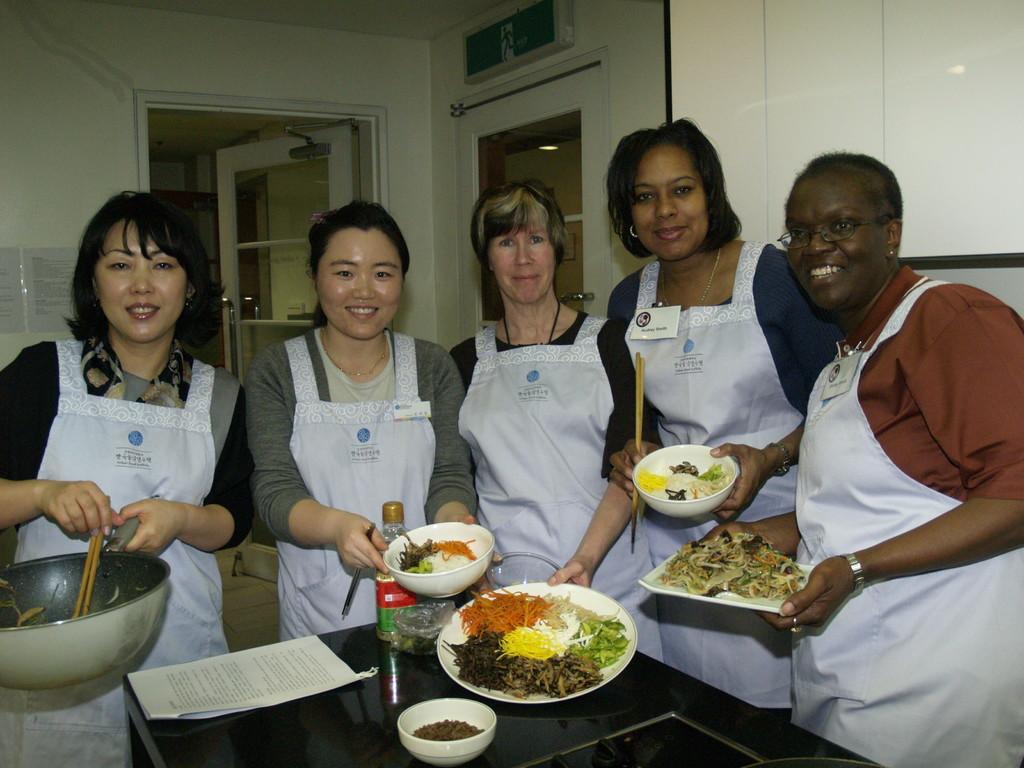Describe this image in one or two sentences. In the center of the image we can see some people are standing and smiling and wearing chef coats and holding plates, bowl which contains food and some of them are holding sticks. At the bottom of the image we can see a table. On the table we can see paper, bottle, cover and a bowl which contains food. In the background of the image we can see the wall, door, rods, boards, paper. 